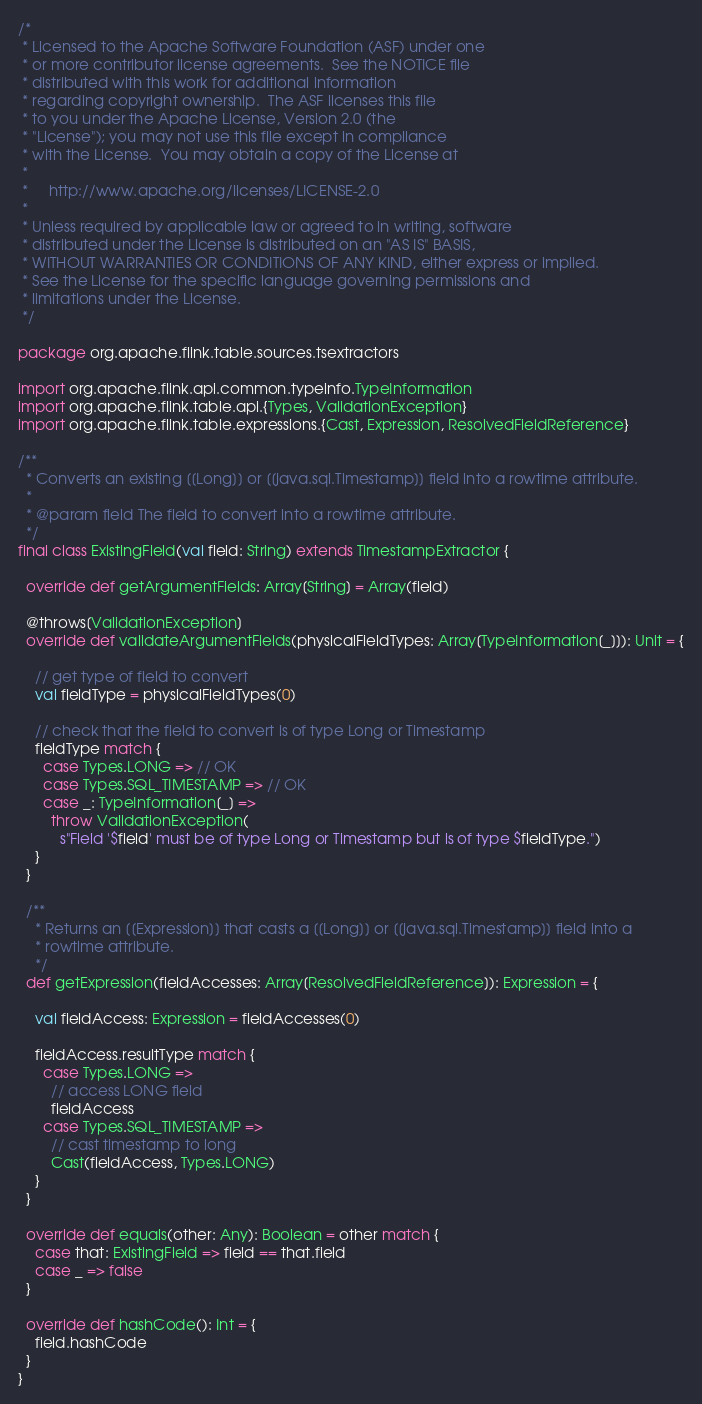Convert code to text. <code><loc_0><loc_0><loc_500><loc_500><_Scala_>/*
 * Licensed to the Apache Software Foundation (ASF) under one
 * or more contributor license agreements.  See the NOTICE file
 * distributed with this work for additional information
 * regarding copyright ownership.  The ASF licenses this file
 * to you under the Apache License, Version 2.0 (the
 * "License"); you may not use this file except in compliance
 * with the License.  You may obtain a copy of the License at
 *
 *     http://www.apache.org/licenses/LICENSE-2.0
 *
 * Unless required by applicable law or agreed to in writing, software
 * distributed under the License is distributed on an "AS IS" BASIS,
 * WITHOUT WARRANTIES OR CONDITIONS OF ANY KIND, either express or implied.
 * See the License for the specific language governing permissions and
 * limitations under the License.
 */

package org.apache.flink.table.sources.tsextractors

import org.apache.flink.api.common.typeinfo.TypeInformation
import org.apache.flink.table.api.{Types, ValidationException}
import org.apache.flink.table.expressions.{Cast, Expression, ResolvedFieldReference}

/**
  * Converts an existing [[Long]] or [[java.sql.Timestamp]] field into a rowtime attribute.
  *
  * @param field The field to convert into a rowtime attribute.
  */
final class ExistingField(val field: String) extends TimestampExtractor {

  override def getArgumentFields: Array[String] = Array(field)

  @throws[ValidationException]
  override def validateArgumentFields(physicalFieldTypes: Array[TypeInformation[_]]): Unit = {

    // get type of field to convert
    val fieldType = physicalFieldTypes(0)

    // check that the field to convert is of type Long or Timestamp
    fieldType match {
      case Types.LONG => // OK
      case Types.SQL_TIMESTAMP => // OK
      case _: TypeInformation[_] =>
        throw ValidationException(
          s"Field '$field' must be of type Long or Timestamp but is of type $fieldType.")
    }
  }

  /**
    * Returns an [[Expression]] that casts a [[Long]] or [[java.sql.Timestamp]] field into a
    * rowtime attribute.
    */
  def getExpression(fieldAccesses: Array[ResolvedFieldReference]): Expression = {

    val fieldAccess: Expression = fieldAccesses(0)

    fieldAccess.resultType match {
      case Types.LONG =>
        // access LONG field
        fieldAccess
      case Types.SQL_TIMESTAMP =>
        // cast timestamp to long
        Cast(fieldAccess, Types.LONG)
    }
  }

  override def equals(other: Any): Boolean = other match {
    case that: ExistingField => field == that.field
    case _ => false
  }

  override def hashCode(): Int = {
    field.hashCode
  }
}
</code> 